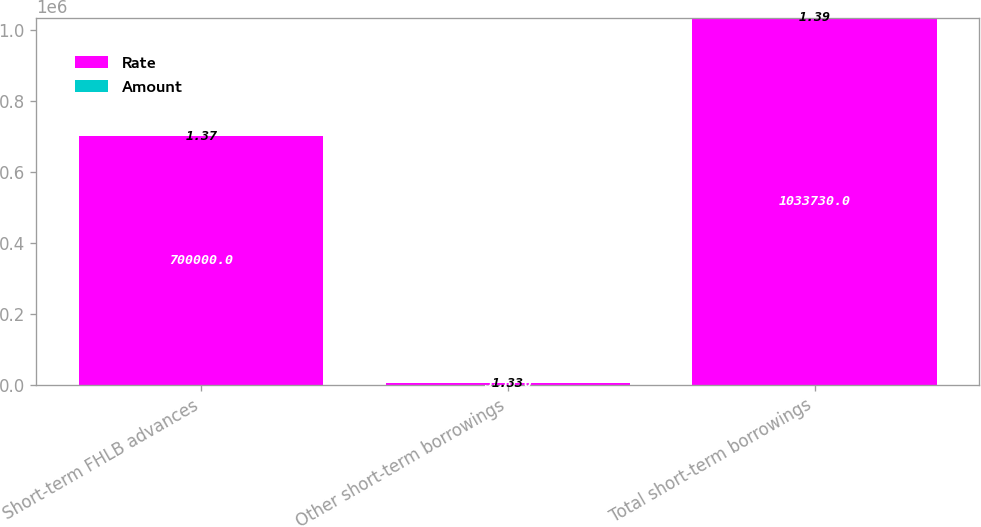Convert chart. <chart><loc_0><loc_0><loc_500><loc_500><stacked_bar_chart><ecel><fcel>Short-term FHLB advances<fcel>Other short-term borrowings<fcel>Total short-term borrowings<nl><fcel>Rate<fcel>700000<fcel>3730<fcel>1.03373e+06<nl><fcel>Amount<fcel>1.37<fcel>1.33<fcel>1.39<nl></chart> 